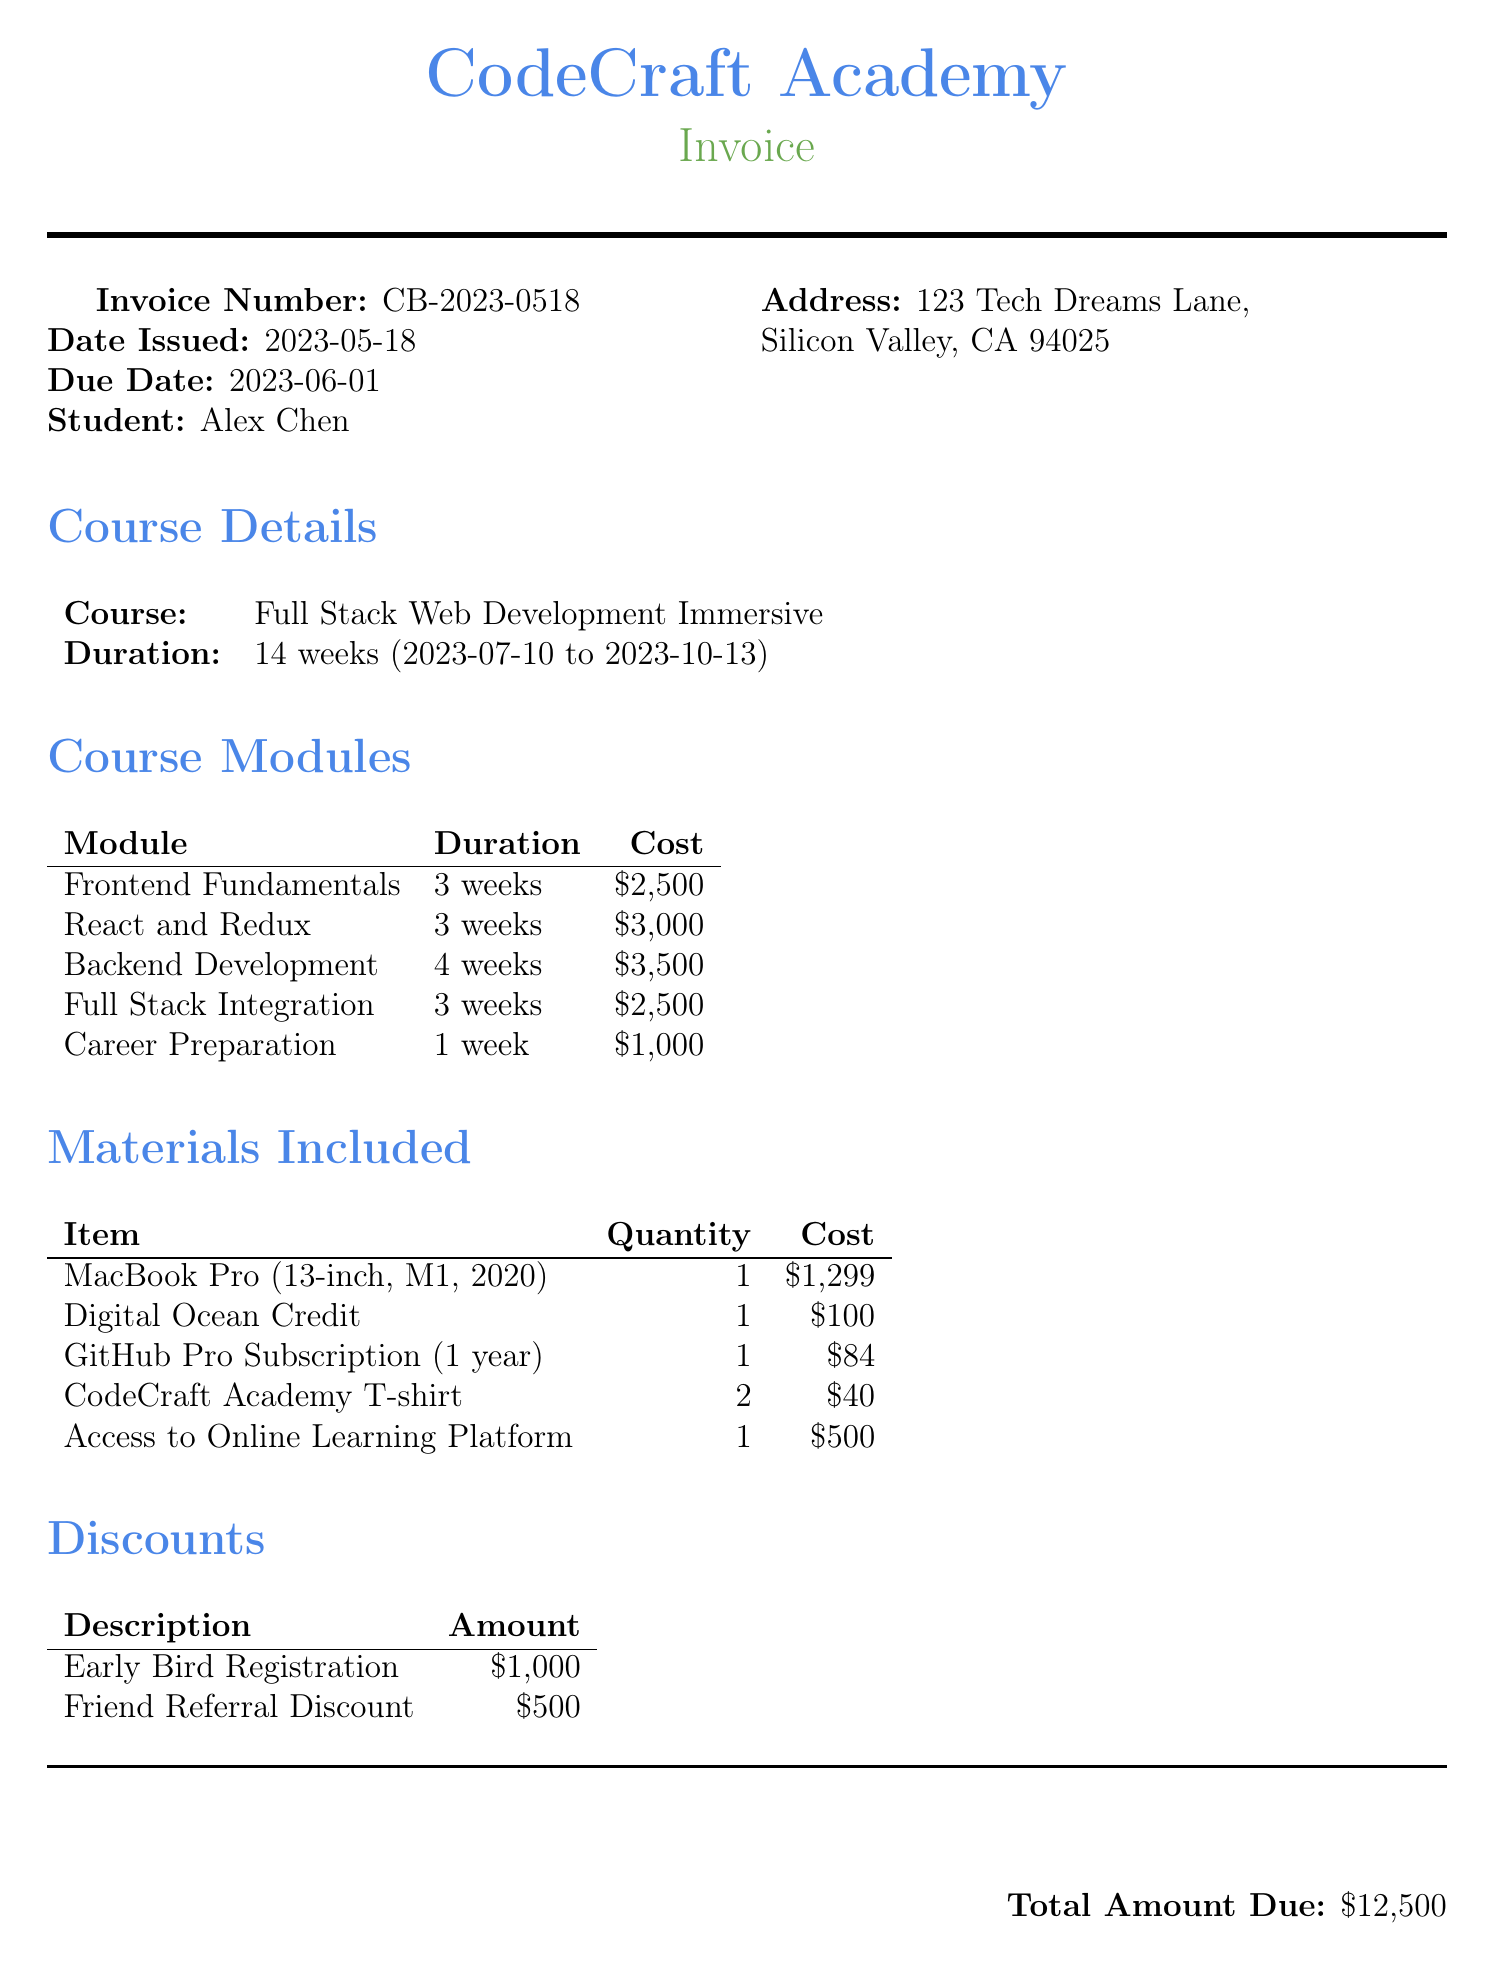What is the invoice number? The invoice number is listed at the top of the document and is unique to this transaction.
Answer: CB-2023-0518 What is the total amount due? The total amount due is summarized clearly towards the end of the document.
Answer: $12,500 Who is the student? The student's name is specified prominently in the document.
Answer: Alex Chen What is the duration of the course? The duration of the course is mentioned in the course details section.
Answer: 14 weeks What discount is provided for early registration? The document lists the discounts and their respective amounts.
Answer: $1,000 How many weeks is the "Backend Development" module? The modules section lists the duration next to each module.
Answer: 4 weeks Which material costs the most? The materials section includes a breakdown of costs, allowing for comparison.
Answer: MacBook Pro (13-inch, M1, 2020) What is the start date of the course? The start date is found in the course details section.
Answer: 2023-07-10 What personal note is included? The document includes a personal note section for encouragement.
Answer: Alex, I'm so proud of you for taking this bold step to pursue your dreams in tech. This bootcamp is the perfect opportunity to turn your lifelong passion into a career. Remember all those late nights we spent coding together? Now you're taking it to the next level. I can't wait to see what amazing things you'll create. You've got this! 